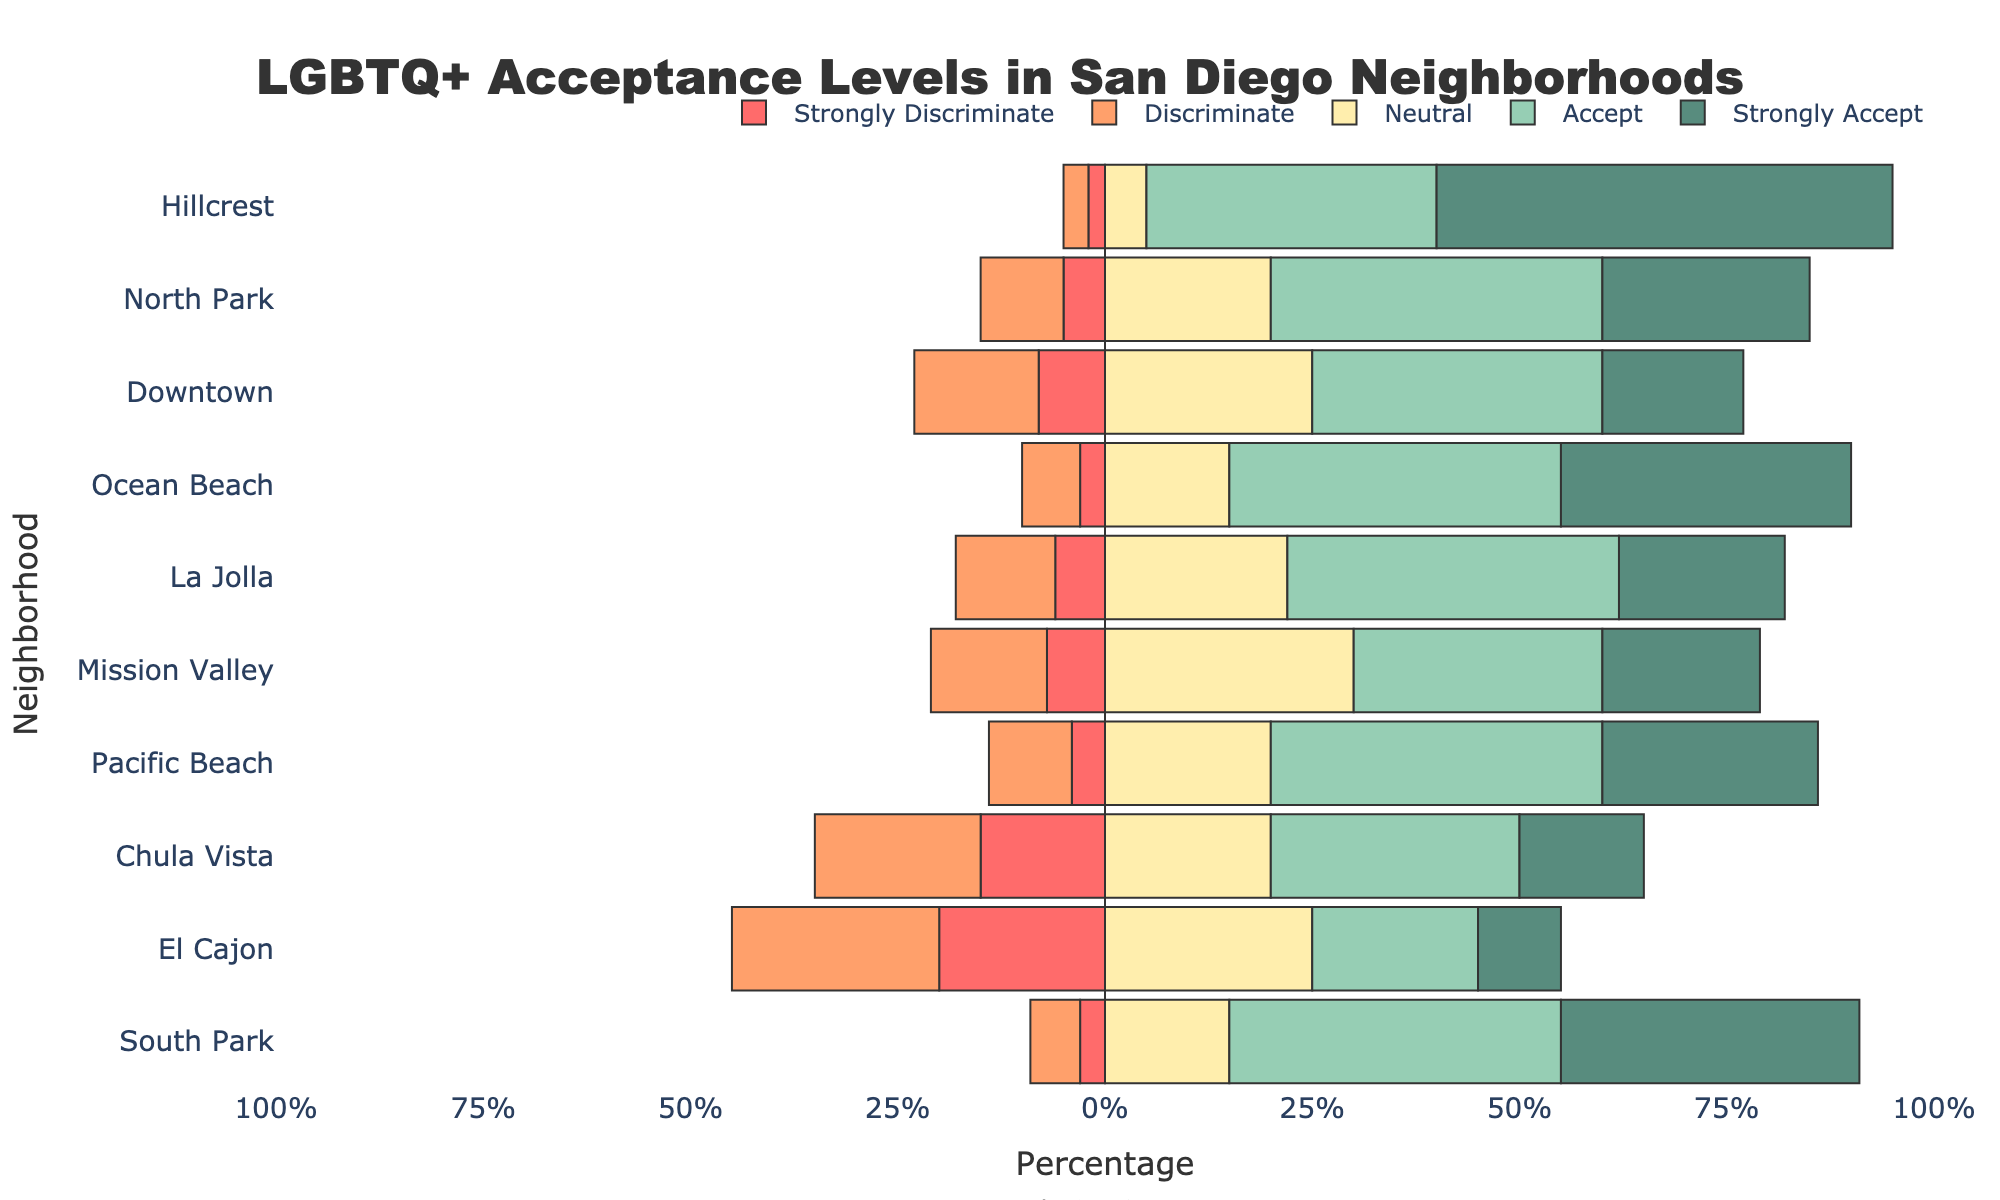Which neighborhood has the highest percentage of people who 'Strongly Accept' the LGBTQ+ community? The bar for 'Strongly Accept' is longest for Hillcrest.
Answer: Hillcrest Which neighborhood shows the highest level of discrimination ('Strongly Discriminate' + 'Discriminate') combined? Sum the lengths of 'Strongly Discriminate' and 'Discriminate' for all neighborhoods; El Cajon has the highest sum.
Answer: El Cajon What is the average percentage of acceptance ('Accept' + 'Strongly Accept') across all neighborhoods? Calculate the sum of percentages for 'Accept' and 'Strongly Accept' for all neighborhoods and divide by the number of neighborhoods.
Answer: 91% Which neighborhoods have a higher percentage of 'Neutral' responses than 'Accept' responses? Compare the lengths of the 'Neutral' and 'Accept' bars for each neighborhood; Downtown and Mission Valley meet this criterion.
Answer: Downtown, Mission Valley What is the total percentage of acceptance ('Accept' + 'Strongly Accept') in Ocean Beach? Sum the percentages of 'Accept' and 'Strongly Accept' in Ocean Beach: 40 + 35 = 75%.
Answer: 75% Which neighborhood has the smallest difference between 'Discriminate' and 'Accept'? Calculate the absolute difference between 'Discriminate' and 'Accept' for all neighborhoods; South Park has the smallest difference.
Answer: South Park What percentage of respondents in Chula Vista are neutral towards the LGBTQ+ community? Refer to the length of the 'Neutral' bar for Chula Vista, which is 20%.
Answer: 20% How many neighborhoods have more than 50% neutral or accepting responses (neutral + accept + strongly accept)? Count the neighborhoods where the combined length of 'Neutral', 'Accept', and 'Strongly Accept' bars exceeds 50%.
Answer: 9 Which neighborhood has the least percentage of strong discrimination (‘Strongly Discriminate’) against the LGBTQ+ community? Look for the shortest 'Strongly Discriminate' bar, which is in Hillcrest.
Answer: Hillcrest In which neighborhoods is the sum of discrimination ('Discriminate' + 'Strongly Discriminate') less than 10%? Calculate the sum of 'Discriminate' and 'Strongly Discriminate' for each neighborhood; Hillcrest, Ocean Beach, and South Park meet this criterion.
Answer: Hillcrest, Ocean Beach, South Park 